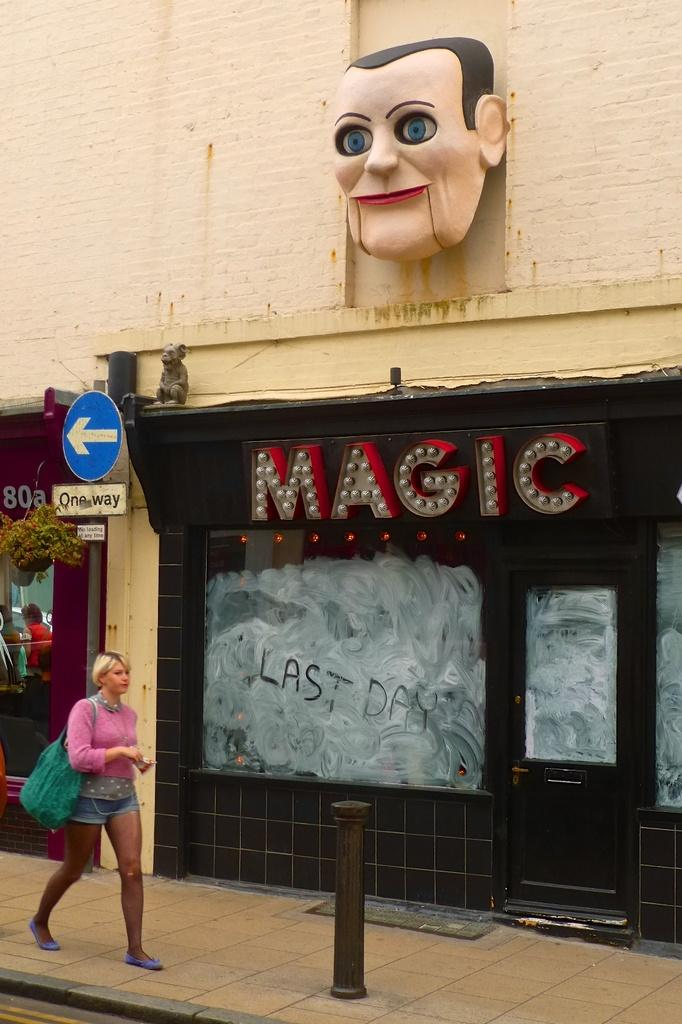What is the girl in the image doing? The girl is walking in the image. Where is the girl walking? The girl is walking on a footpath. What is located beside the girl? There is a store beside the girl. What type of display is present on the store? The store has a LED hoarding. What can be seen at the top of the image? There is a statue of a face at the top of the image. What is the girl's current debt situation in the image? There is no information about the girl's debt situation in the image. What additional detail can be seen on the girl's clothing in the image? The provided facts do not mention any specific details about the girl's clothing. 